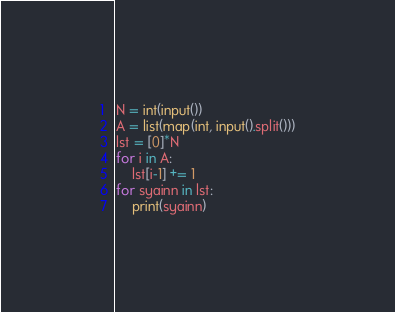<code> <loc_0><loc_0><loc_500><loc_500><_Python_>N = int(input())
A = list(map(int, input().split()))
lst = [0]*N
for i in A:
    lst[i-1] += 1
for syainn in lst:
    print(syainn)</code> 